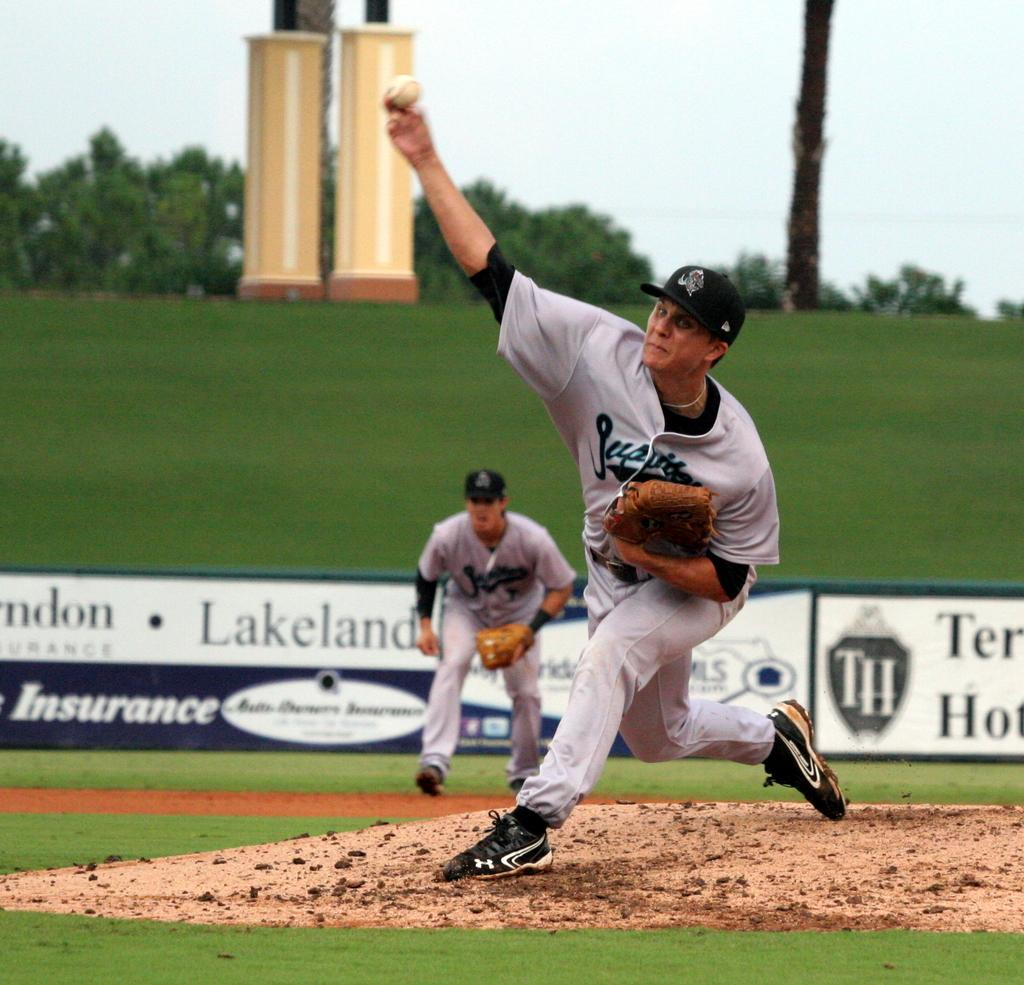<image>
Present a compact description of the photo's key features. A baseball pitcher is throwing the ball and a sign behind him says Insurance. 